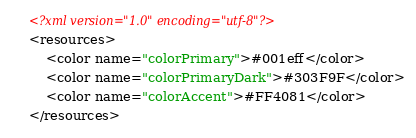<code> <loc_0><loc_0><loc_500><loc_500><_XML_><?xml version="1.0" encoding="utf-8"?>
<resources>
    <color name="colorPrimary">#001eff</color>
    <color name="colorPrimaryDark">#303F9F</color>
    <color name="colorAccent">#FF4081</color>
</resources>
</code> 